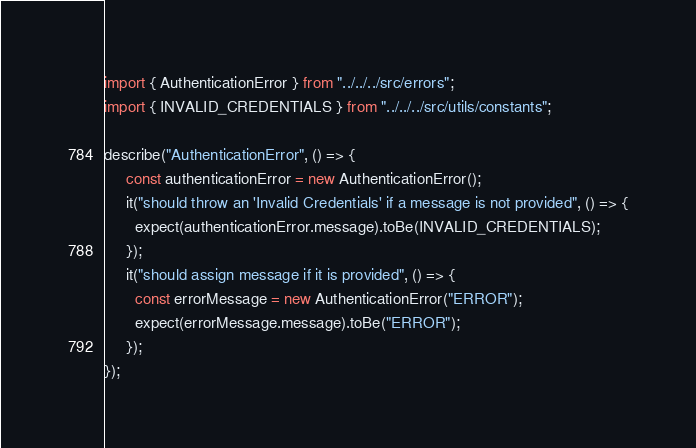Convert code to text. <code><loc_0><loc_0><loc_500><loc_500><_JavaScript_>import { AuthenticationError } from "../../../src/errors";
import { INVALID_CREDENTIALS } from "../../../src/utils/constants";

describe("AuthenticationError", () => {
     const authenticationError = new AuthenticationError();
     it("should throw an 'Invalid Credentials' if a message is not provided", () => {
       expect(authenticationError.message).toBe(INVALID_CREDENTIALS);
     });
     it("should assign message if it is provided", () => {
       const errorMessage = new AuthenticationError("ERROR");
       expect(errorMessage.message).toBe("ERROR");
     });
});
</code> 